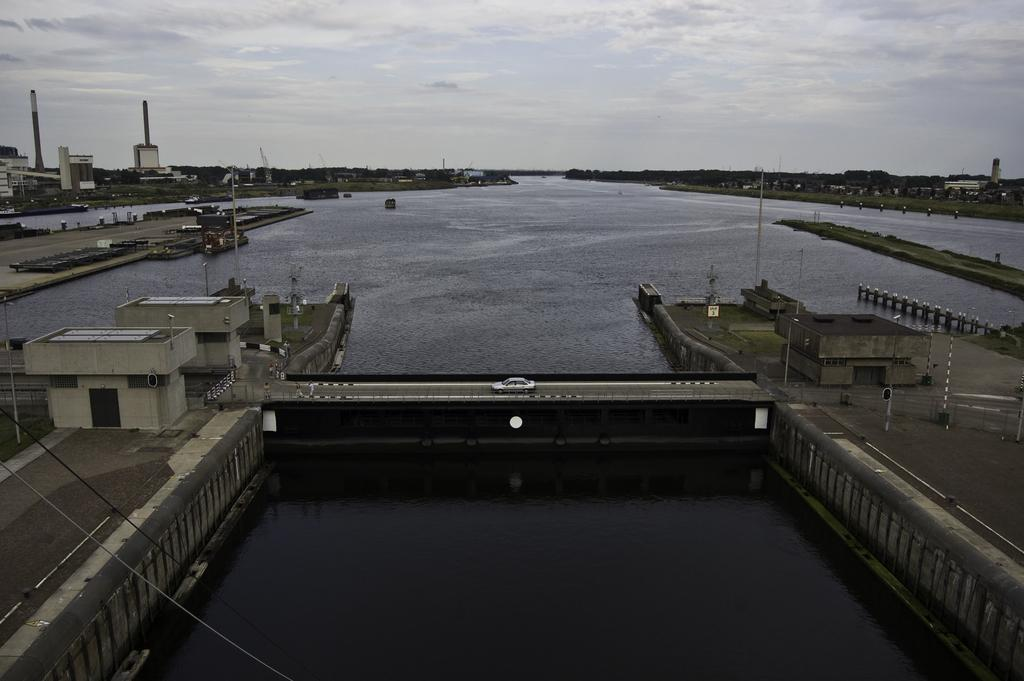What type of structures can be seen in the image? There are buildings in the image. What natural element is visible in the image? There is water visible in the image. What mode of transportation can be seen in the image? There is a vehicle in the image. What are the tall, thin objects in the image? There are poles in the image. What type of vegetation is present in the image? There are trees in the image. What is visible in the background of the image? The sky is visible in the background of the image. What type of pie is being served with a spoon in the image? There is no pie or spoon present in the image; it features buildings, water, a vehicle, poles, trees, and the sky. 